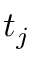Convert formula to latex. <formula><loc_0><loc_0><loc_500><loc_500>t _ { j }</formula> 